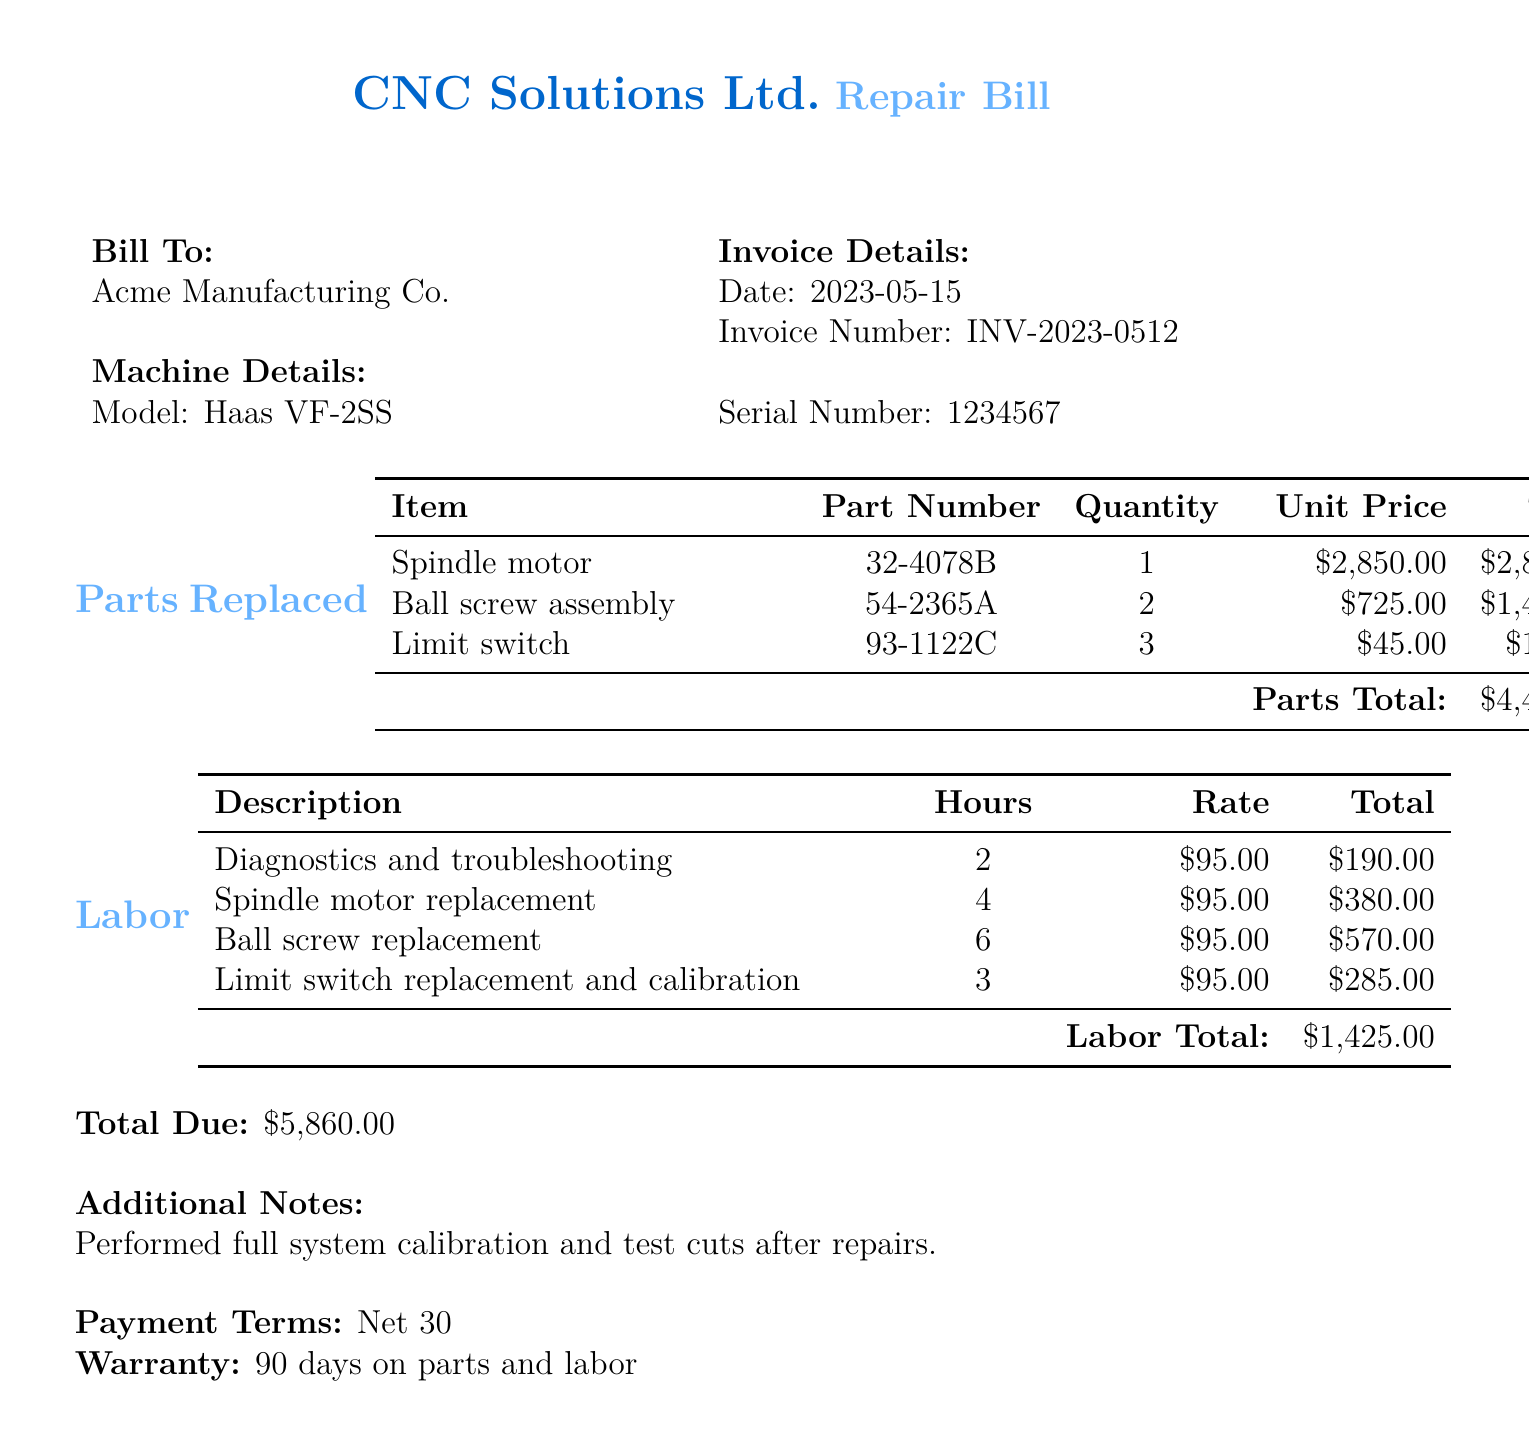what is the total due? The total due is the final amount to be paid as listed in the document.
Answer: $5,860.00 what is the date of the invoice? The date of the invoice is specified in the document under invoice details.
Answer: 2023-05-15 how many limit switches were replaced? The document lists the quantity of limit switches replaced in the parts section.
Answer: 3 what is the unit price of the spindle motor? The unit price is provided in the parts replaced section of the document.
Answer: $2,850.00 what is the warranty period for parts and labor? The warranty information is specified towards the end of the document.
Answer: 90 days how many hours were spent on ball screw replacement? The hours spent on ball screw replacement are detailed in the labor section of the document.
Answer: 6 what is the total cost for labor? The labor total is the sum of all labor charges as outlined in the labor section.
Answer: $1,425.00 who is the bill addressed to? The recipient of the bill is listed in the bill to section.
Answer: Acme Manufacturing Co what additional work was performed after repairs? The additional notes section specifies any work done beyond repairs.
Answer: Full system calibration and test cuts 